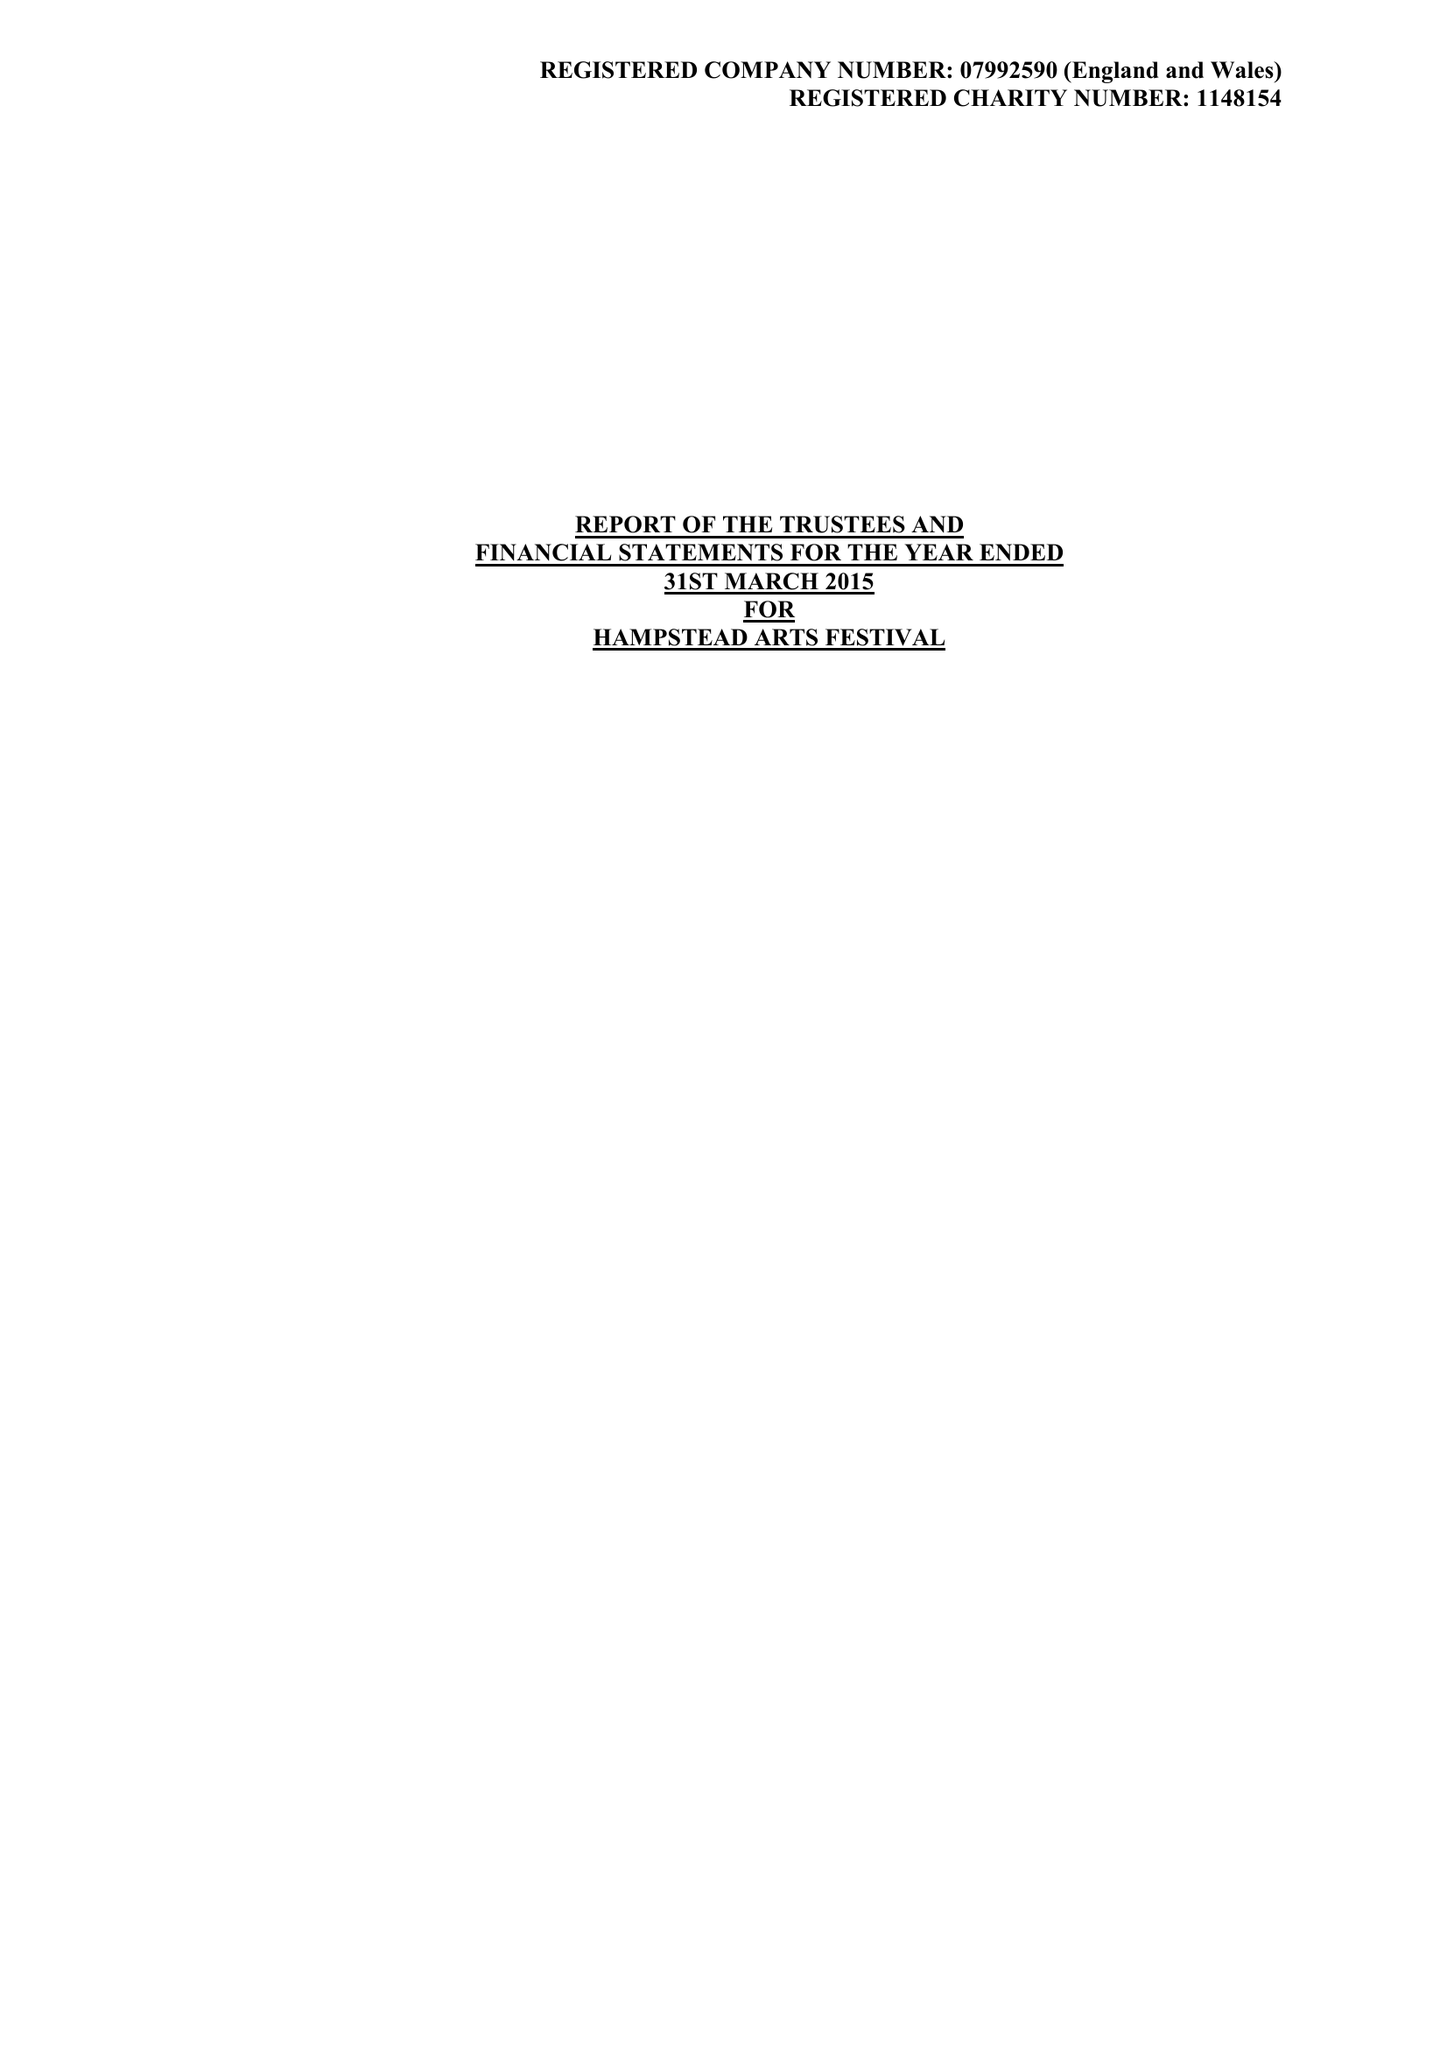What is the value for the address__post_town?
Answer the question using a single word or phrase. HARROW 